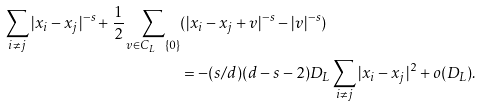Convert formula to latex. <formula><loc_0><loc_0><loc_500><loc_500>\sum _ { i \neq j } | x _ { i } - x _ { j } | ^ { - s } + \frac { 1 } { 2 } \sum _ { v \in C _ { L } \ \{ 0 \} } & ( | x _ { i } - x _ { j } + v | ^ { - s } - | v | ^ { - s } ) \\ & = - ( s / d ) ( d - s - 2 ) D _ { L } \sum _ { i \neq j } | x _ { i } - x _ { j } | ^ { 2 } + o ( D _ { L } ) .</formula> 